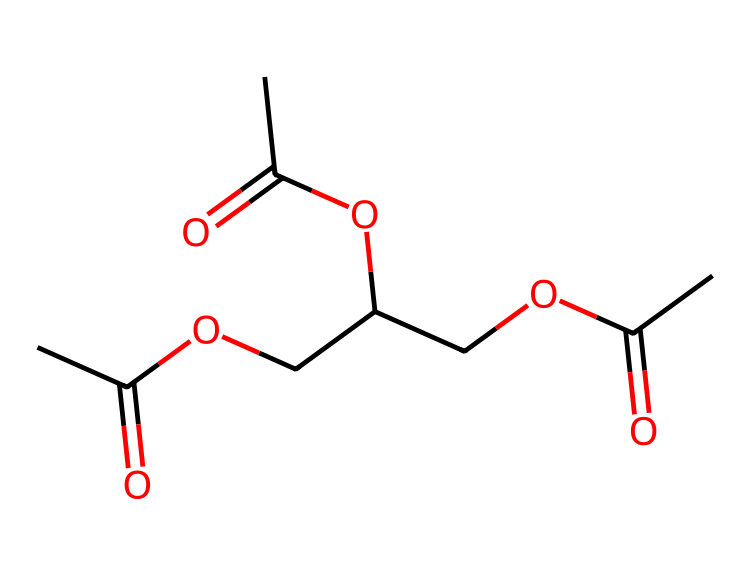What is the molecular formula of this compound? By counting the atoms represented in the SMILES notation, we deduce the molecular formula by identifying carbon (C), hydrogen (H), and oxygen (O) atoms. In this SMILES, there are 12 carbon atoms, 22 hydrogen atoms, and 6 oxygen atoms. Thus, the molecular formula is determined to be C12H22O6.
Answer: C12H22O6 How many ester functional groups are present in the structure? To identify ester functional groups, we look for the characteristic -COO- linkage. In the SMILES, we can find three instances of this linkage, indicating the presence of three ester functional groups in the structure.
Answer: 3 What type of chemical is this compound classified as? This compound is primarily classified as an ester because it contains multiple ester groups and is characteristic of fragrances and flavors, often used in air fresheners.
Answer: ester What is the total number of atoms in the molecule? The total number of atoms can be calculated by adding up all the individual atoms present. From the molecular formula C12H22O6, we can sum the atoms: 12 carbons + 22 hydrogens + 6 oxygens gives us a total of 40 atoms.
Answer: 40 Which part of this compound contributes to its sweet fragrance? The sweet fragrance in this compound can be attributed to the ester groups present. Esters typically have fruity and sweet odors, which is common among air fresheners like vanilla.
Answer: ester groups Does this compound contain any cyclic structures? By analyzing the SMILES representation, we note that there are no ring structures indicated. All carbon atoms form linear or branched chains without any cycles present in the composition.
Answer: no 